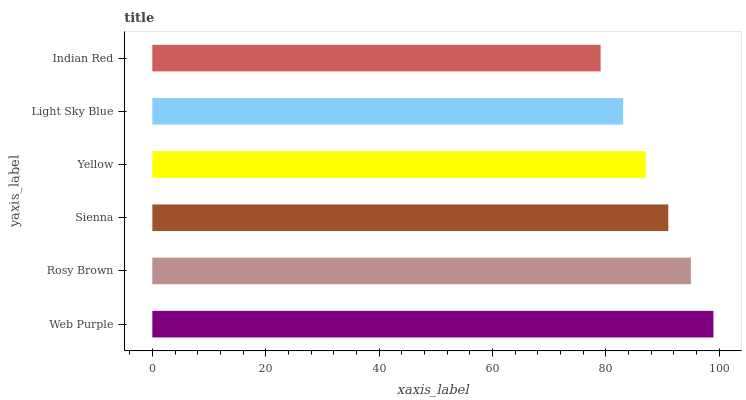Is Indian Red the minimum?
Answer yes or no. Yes. Is Web Purple the maximum?
Answer yes or no. Yes. Is Rosy Brown the minimum?
Answer yes or no. No. Is Rosy Brown the maximum?
Answer yes or no. No. Is Web Purple greater than Rosy Brown?
Answer yes or no. Yes. Is Rosy Brown less than Web Purple?
Answer yes or no. Yes. Is Rosy Brown greater than Web Purple?
Answer yes or no. No. Is Web Purple less than Rosy Brown?
Answer yes or no. No. Is Sienna the high median?
Answer yes or no. Yes. Is Yellow the low median?
Answer yes or no. Yes. Is Yellow the high median?
Answer yes or no. No. Is Light Sky Blue the low median?
Answer yes or no. No. 